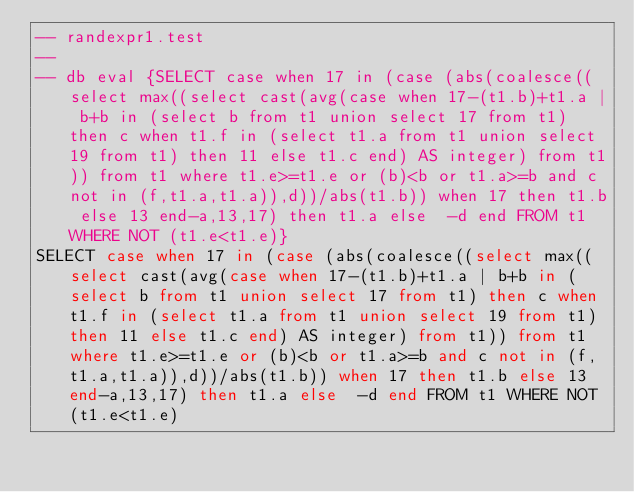Convert code to text. <code><loc_0><loc_0><loc_500><loc_500><_SQL_>-- randexpr1.test
-- 
-- db eval {SELECT case when 17 in (case (abs(coalesce((select max((select cast(avg(case when 17-(t1.b)+t1.a | b+b in (select b from t1 union select 17 from t1) then c when t1.f in (select t1.a from t1 union select 19 from t1) then 11 else t1.c end) AS integer) from t1)) from t1 where t1.e>=t1.e or (b)<b or t1.a>=b and c not in (f,t1.a,t1.a)),d))/abs(t1.b)) when 17 then t1.b else 13 end-a,13,17) then t1.a else  -d end FROM t1 WHERE NOT (t1.e<t1.e)}
SELECT case when 17 in (case (abs(coalesce((select max((select cast(avg(case when 17-(t1.b)+t1.a | b+b in (select b from t1 union select 17 from t1) then c when t1.f in (select t1.a from t1 union select 19 from t1) then 11 else t1.c end) AS integer) from t1)) from t1 where t1.e>=t1.e or (b)<b or t1.a>=b and c not in (f,t1.a,t1.a)),d))/abs(t1.b)) when 17 then t1.b else 13 end-a,13,17) then t1.a else  -d end FROM t1 WHERE NOT (t1.e<t1.e)</code> 